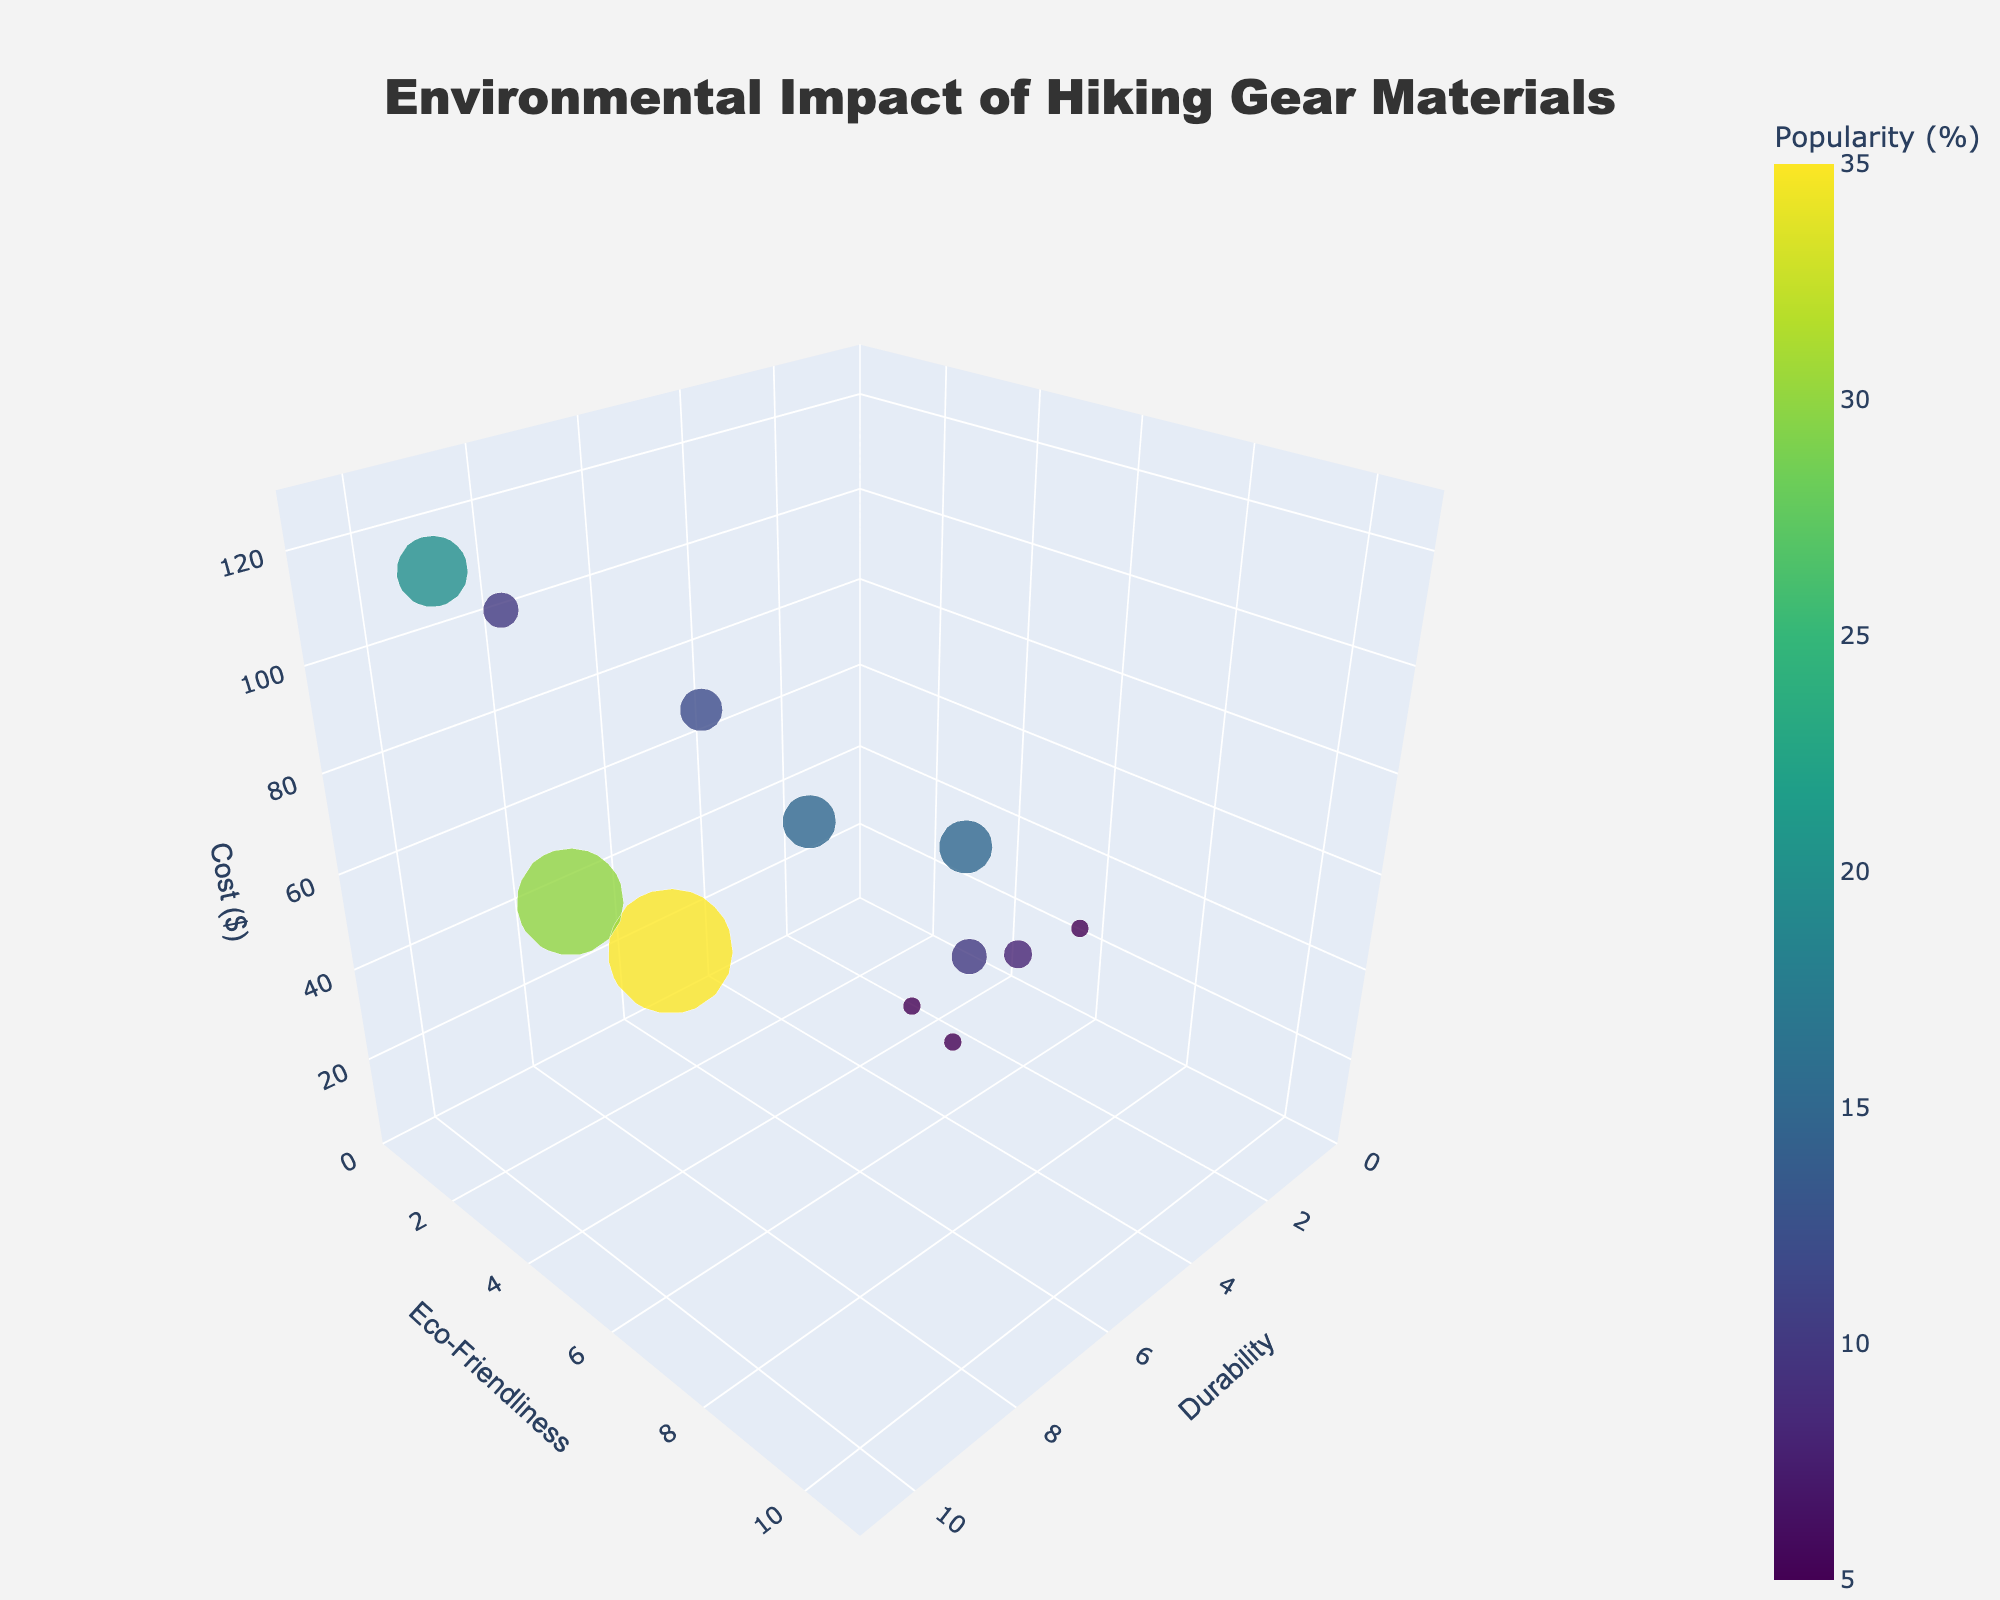What is the title of the figure? The title is displayed at the top of the figure. It reads: "Environmental Impact of Hiking Gear Materials."
Answer: Environmental Impact of Hiking Gear Materials Which material has the highest durability? To determine this, look at the materials plotted on the x-axis and find the one with the highest value. Gore-Tex has the highest durability at 10.
Answer: Gore-Tex What is the most eco-friendly material? Check the y-axis values for the most eco-friendly material. Cork has the highest eco-friendly rating at 10.
Answer: Cork Which material has the lowest cost? Look at the z-axis, which represents the cost. Cotton, with a cost of $30, has the lowest value.
Answer: Cotton Which materials have both an eco-friendliness score above 7 and a durability score above 6? Identify materials with values above these thresholds on both the x and y axes. Recycled Plastic, Bamboo Fiber, and Hemp fit these criteria.
Answer: Recycled Plastic, Bamboo Fiber, Hemp Which material is the most expensive? Locate the material with the highest value on the z-axis. Gore-Tex has the highest cost at $120.
Answer: Gore-Tex How does the popularity affect the size of the bubbles? Larger bubbles represent more popular materials. The size of each bubble is determined by the popularity percentage, with larger bubbles for higher popularity values.
Answer: Larger bubbles mean more popularity Compare the cost of Merino Wool and Synthetic Insulation. Which one is more expensive? Check the z-axis values for both materials. Merino Wool costs $80, while Synthetic Insulation also costs $80. They are equally priced.
Answer: Merino Wool, Synthetic Insulation What is the relationship between eco-friendliness and cost for Recycled Plastic? Recycled Plastic has an eco-friendliness score of 9 and a cost of $70. The trend suggests that this material is both eco-friendly and moderately priced.
Answer: Eco-friendly and moderately costly 